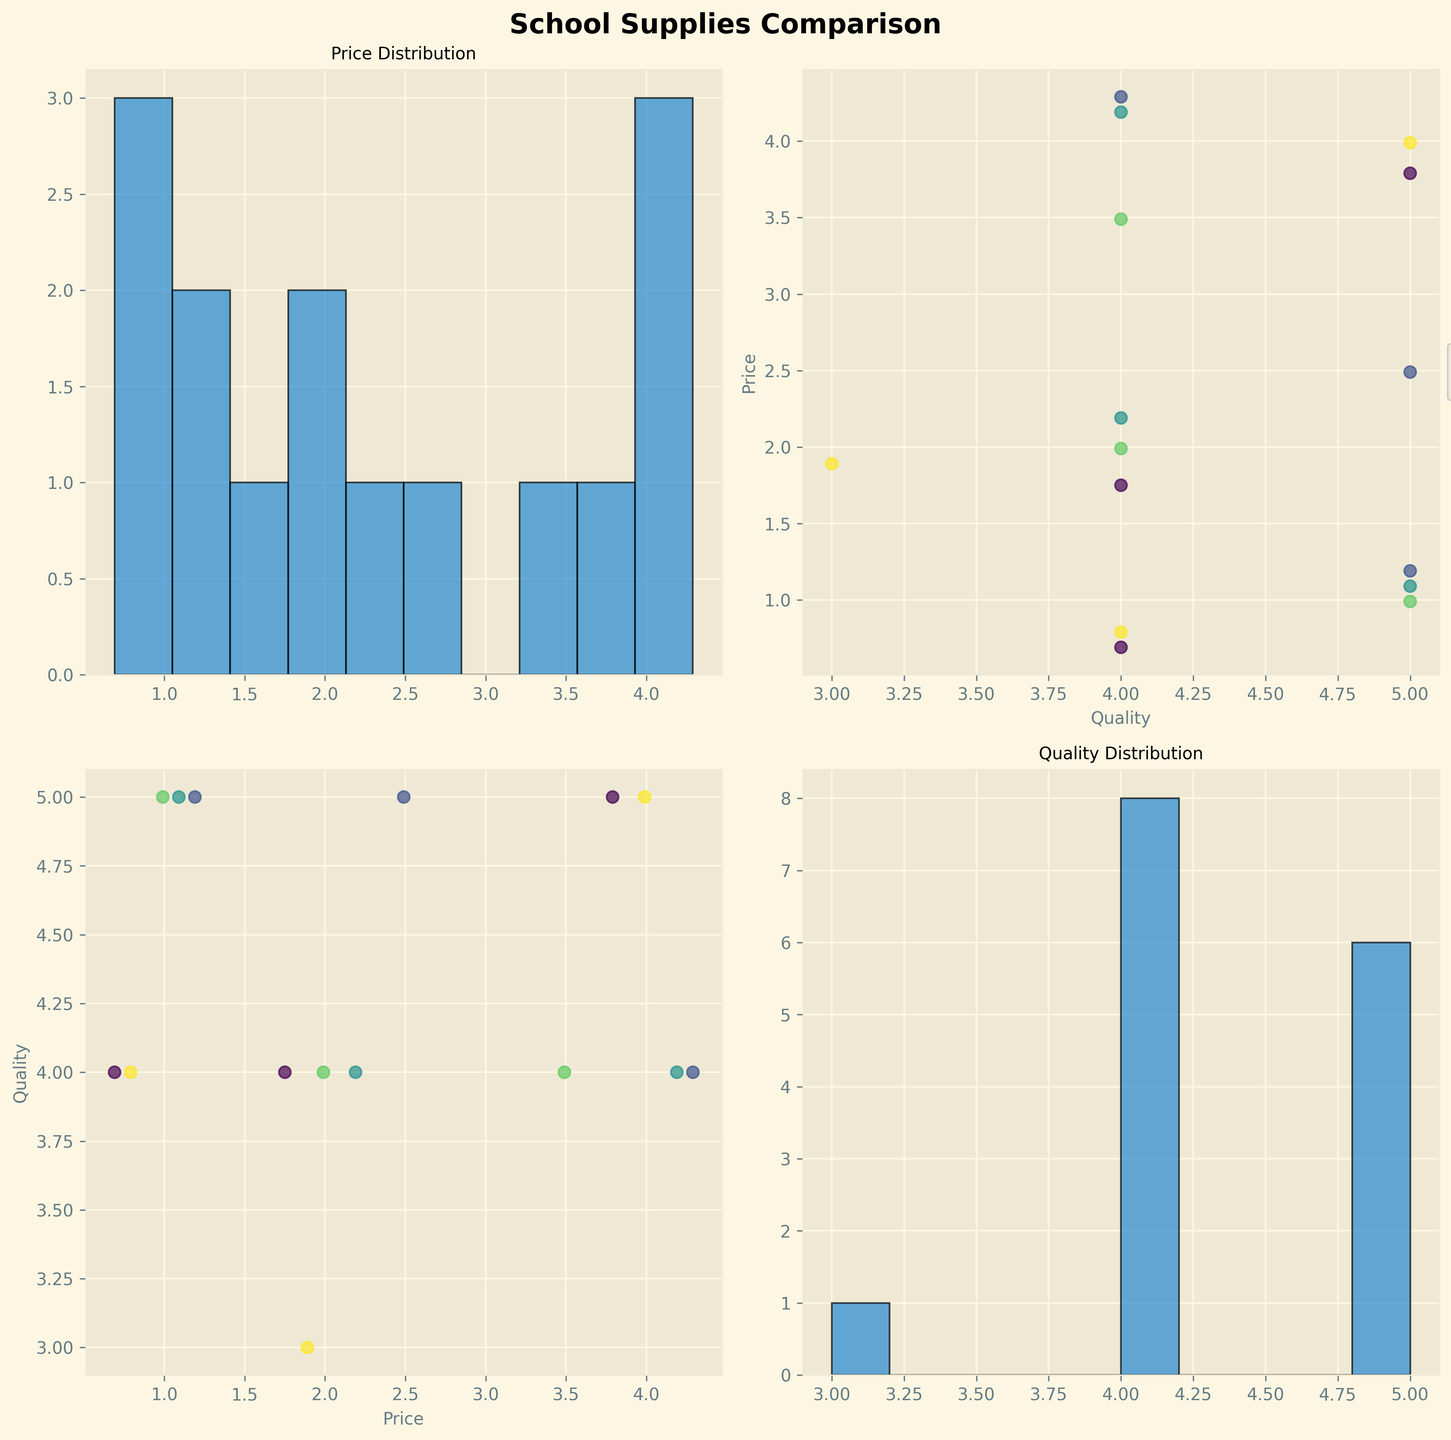What's the title of the figure? The title of the figure is displayed prominently at the top of the SPLOM. It reads "School Supplies Comparison."
Answer: School Supplies Comparison What are the variables represented in the scatter plots and histograms? The scatter plots and histograms show data for "Price" and "Quality." These are the variables used in the numeric comparisons.
Answer: Price and Quality How is color used in the scatter plots? In the scatter plots, different colors represent different stores. The colors help to distinguish between data points from Target, Walmart, Office Depot, Amazon, and Staples.
Answer: To represent different stores Which store has the lowest overall price for Notebooks? By examining the scatter plots and identifying the symbol corresponding to each store, Amazon appears to have the lowest price for Notebooks at $1.75.
Answer: Amazon Which quality rating is most frequent across the school supplies? This can be seen from the histogram for the "Quality" variable. The most frequent quality rating appears to be 4, as its bar is the tallest.
Answer: 4 Is there any noticeable relationship between price and quality for school supplies? From the scatter plot comparing Price and Quality, there doesn't appear to be a strong relationship. The data points are scattered fairly evenly across different quality ratings and price levels.
Answer: No strong relationship Which store tends to have the highest prices for binders? By comparing the highest points in the Price and Quality scatter plots, Office Depot and Staples show higher prices for binders, with Office Depot's Binder priced at $4.29.
Answer: Office Depot Which two categories of items have the closest prices across different stores? By comparing scatter plots of Price vs. Item categories for different stores, it is evident that Pencils and Notebooks have prices that are closer to each other across different stores.
Answer: Pencils and Notebooks Are online shopping options cheaper on average compared to in-store shopping? By comparing the average prices for items listed as "Online Only" against those available "In-store," Amazon, which offers online options, tends to have slightly lower prices, particularly for Notebooks and Pencils.
Answer: Yes 